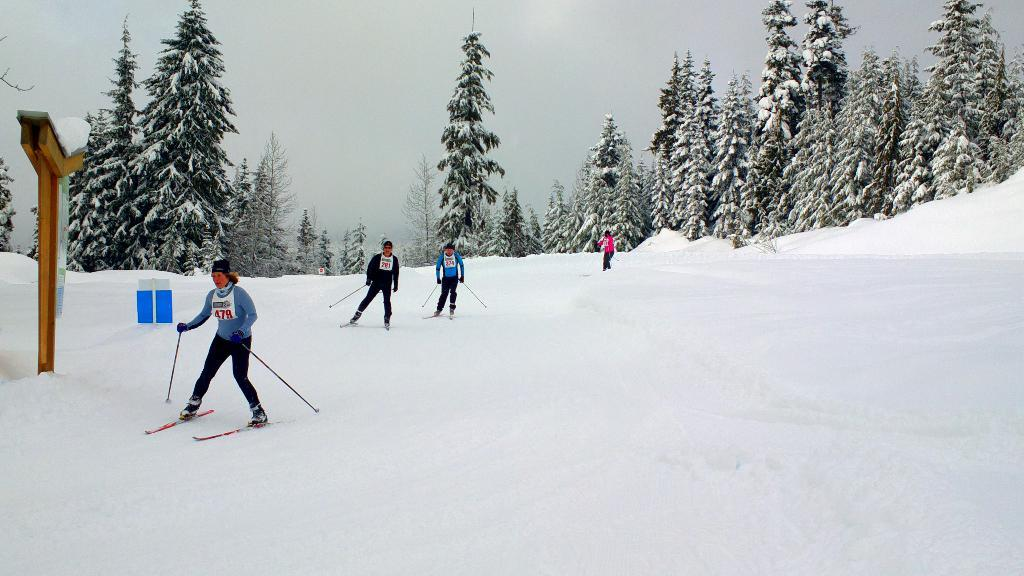What type of vegetation can be seen in the image? There are trees in the image. What activity are the people engaged in? There are people skiing in the image. What is the condition of the ground in the image? There is snow on the ground in the image. What object can be seen in the image that is made of wood? There is a wooden pole in the image. What is the weather like in the image? The sky is cloudy in the image. How many friends are visible in the image? The provided facts do not mention any friends in the image, so we cannot determine the number of friends present. What type of hole can be seen in the image? There is no hole present in the image. 